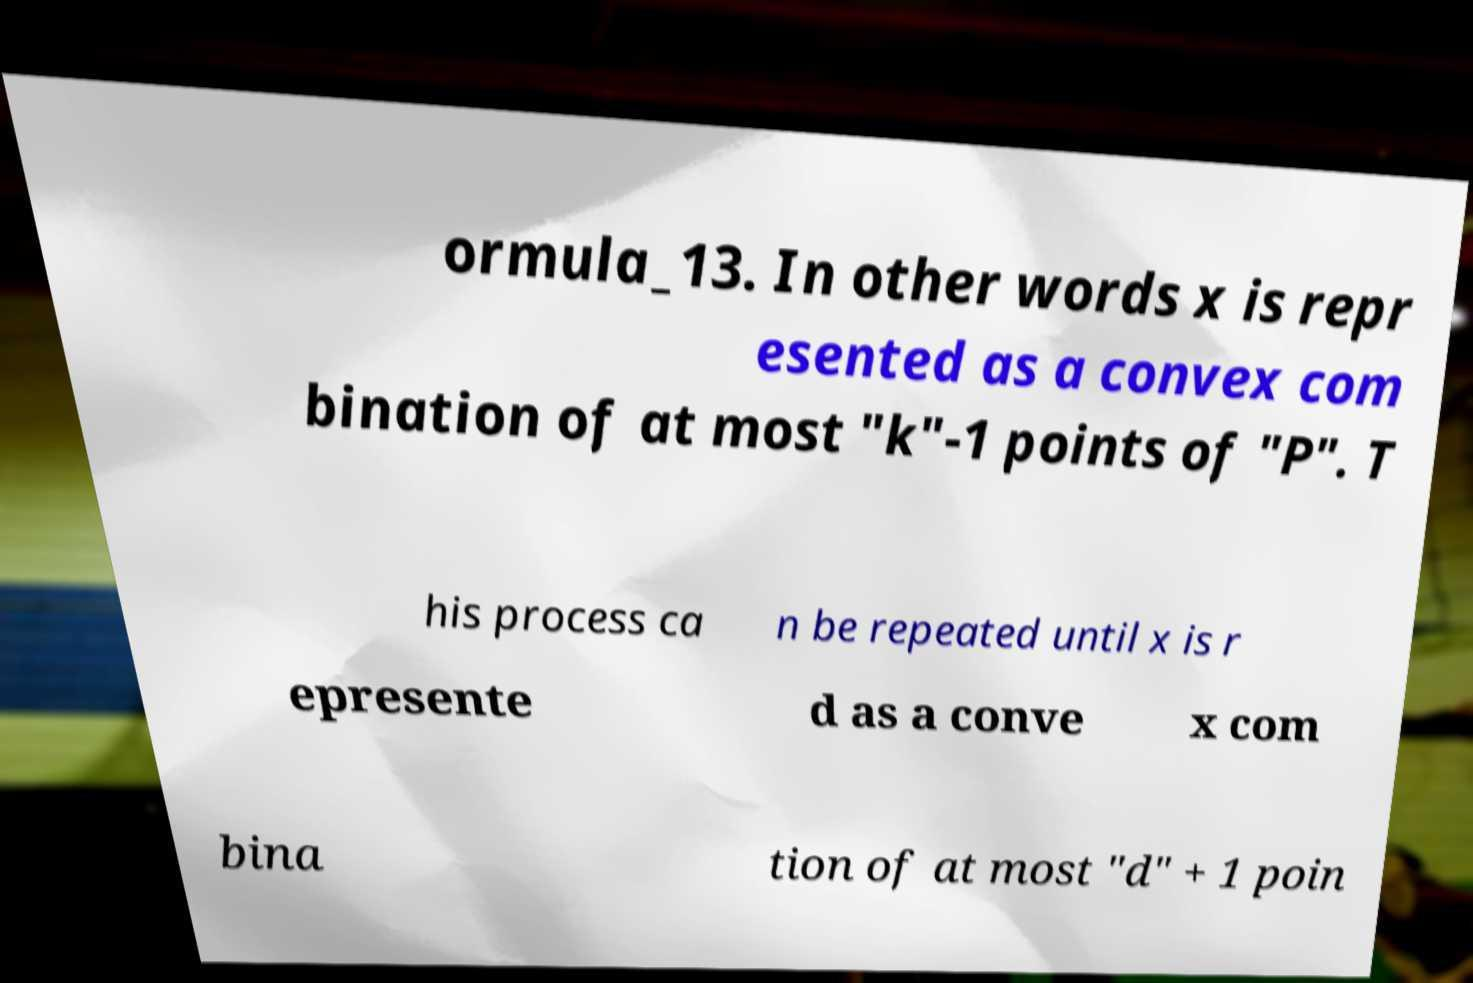Could you assist in decoding the text presented in this image and type it out clearly? ormula_13. In other words x is repr esented as a convex com bination of at most "k"-1 points of "P". T his process ca n be repeated until x is r epresente d as a conve x com bina tion of at most "d" + 1 poin 